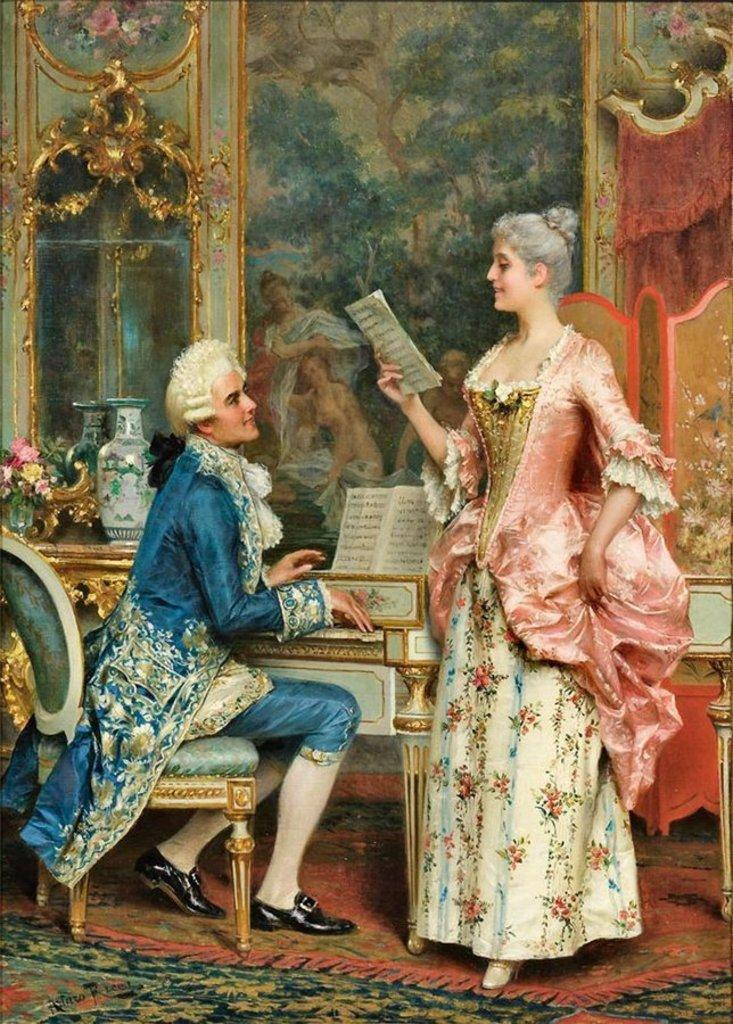What is the main subject of the image? There is a picture in the image. What can be seen in the picture? In the picture, there is a man sitting on a chair, a woman standing on the floor, a carpet, a table, a vase, and mirrors. Can you describe the furniture in the picture? In the picture, there is a chair and a table. What type of decorative item is present in the picture? In the picture, there is a vase. How far away is the beetle from the egg in the image? There is no beetle or egg present in the image. What type of egg can be seen in the picture? There is no egg present in the picture. 